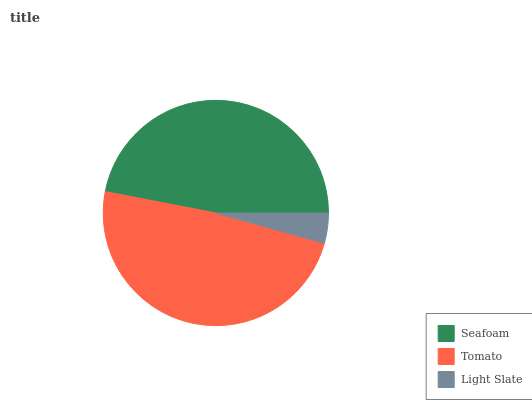Is Light Slate the minimum?
Answer yes or no. Yes. Is Tomato the maximum?
Answer yes or no. Yes. Is Tomato the minimum?
Answer yes or no. No. Is Light Slate the maximum?
Answer yes or no. No. Is Tomato greater than Light Slate?
Answer yes or no. Yes. Is Light Slate less than Tomato?
Answer yes or no. Yes. Is Light Slate greater than Tomato?
Answer yes or no. No. Is Tomato less than Light Slate?
Answer yes or no. No. Is Seafoam the high median?
Answer yes or no. Yes. Is Seafoam the low median?
Answer yes or no. Yes. Is Light Slate the high median?
Answer yes or no. No. Is Light Slate the low median?
Answer yes or no. No. 